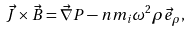<formula> <loc_0><loc_0><loc_500><loc_500>\vec { J } \times \vec { B } = \vec { \nabla } P - n m _ { i } \omega ^ { 2 } \rho \vec { e } _ { \rho } ,</formula> 